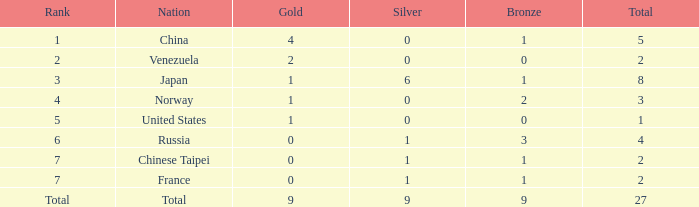What is the aggregate amount of bronze when gold surpasses 1 and the country is comprehensive? 1.0. 